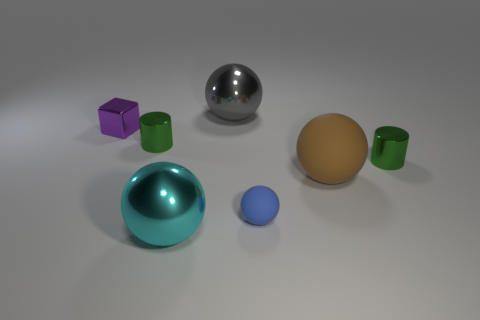Subtract all tiny blue balls. How many balls are left? 3 Subtract all gray balls. How many balls are left? 3 Subtract 1 spheres. How many spheres are left? 3 Add 3 brown matte things. How many objects exist? 10 Subtract all purple spheres. Subtract all brown blocks. How many spheres are left? 4 Subtract all blocks. How many objects are left? 6 Add 5 tiny blue rubber balls. How many tiny blue rubber balls exist? 6 Subtract 0 brown cubes. How many objects are left? 7 Subtract all large red matte cubes. Subtract all large rubber balls. How many objects are left? 6 Add 6 tiny rubber balls. How many tiny rubber balls are left? 7 